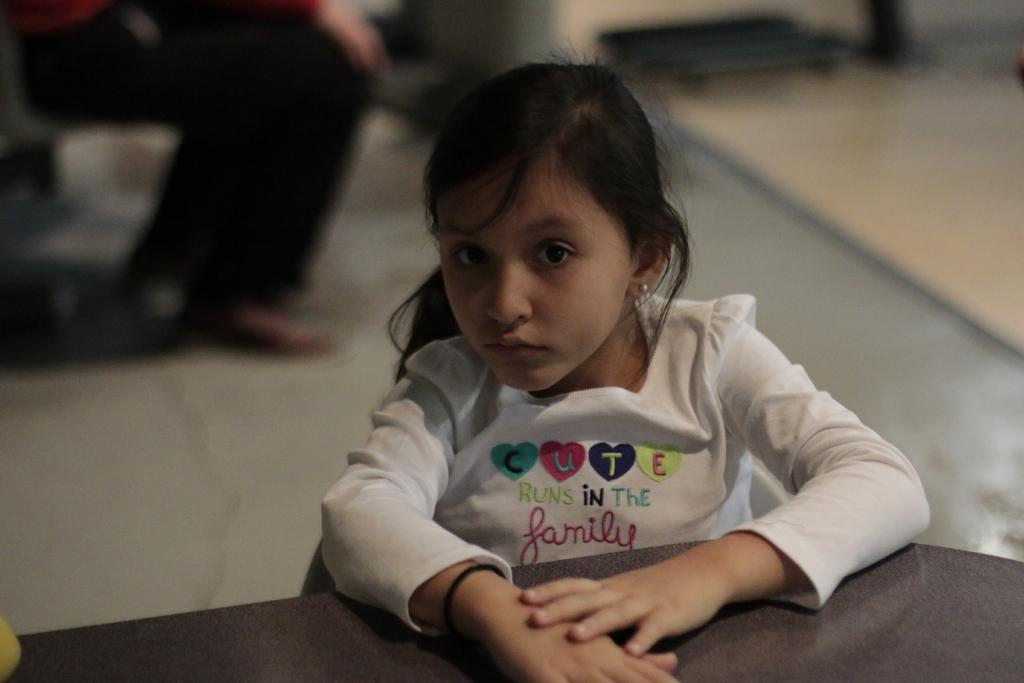What is the person in the image wearing? The person in the image is wearing a white dress. What can be seen in front of the person? There is a black table in front of the person. Can you describe the background of the image? The background of the image is blurred. What year is the carpenter working in the image? There is no carpenter or any indication of a specific year in the image. 